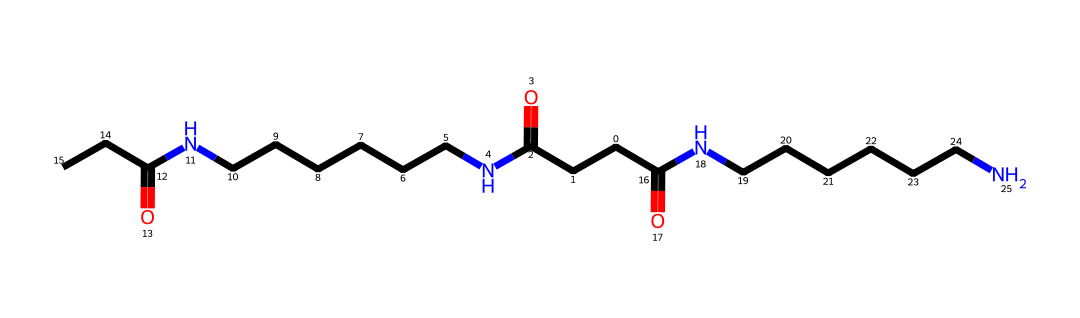How many nitrogen atoms are present in this chemical structure? Looking at the SMILES representation, I can identify each nitrogen atom represented by 'N.' By counting the occurrences of 'N' in the chemical structure, I find that there are four nitrogen atoms.
Answer: four What is the main functional group present in this polymer structure? The structure has several amide linkages which are indicated by the presence of 'C(=O)N' in the SMILES. This signifies that the main functional group is the amide.
Answer: amide How many carbon atoms are in this chemical? By examining the SMILES representation, I can count all the 'C' appearances, which indicate carbon atoms. There are a total of 16 carbon atoms in the structure.
Answer: sixteen What type of polymer is indicated by this chemical structure? The presence of multiple amide linkages and the repetitive nature of the structure suggest that this is a polyamide, commonly known as nylon.
Answer: polyamide What is the significance of the repeating units in this polymer? Repeating units in a polymer like this one determine its overall properties, such as strength and flexibility. The lengths and arrangements of these units affect the performance of nylon in applications such as sports jerseys.
Answer: properties Which part of this chemical structure contributes to its strength? The presence of strong hydrogen bonding between amide groups contributes significantly to the strength of this polymer. The ability for these groups to interact helps in providing tensile strength to materials like jerseys.
Answer: hydrogen bonding 